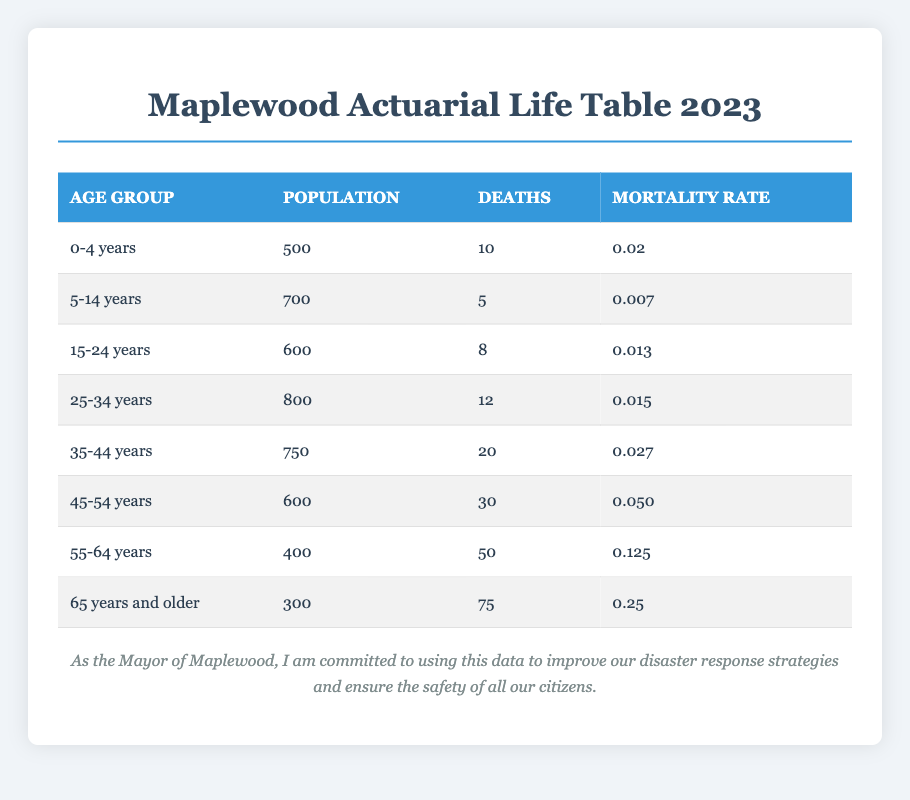What is the mortality rate for the age group 25-34 years? The table indicates that the mortality rate for the 25-34 year age group is listed directly under that category, which is 0.015.
Answer: 0.015 How many deaths were recorded in the age group 55-64 years? The number of deaths in the 55-64 year age group is noted in the table, and it shows a total of 50 deaths.
Answer: 50 What is the total population of the age groups 0-4 years and 5-14 years combined? To find the total population of the two age groups, we sum the populations: 500 (0-4 years) + 700 (5-14 years) = 1200.
Answer: 1200 Is the mortality rate for the age group 15-24 years higher than that for the age group 0-4 years? The mortality rate for 15-24 years is 0.013, compared to 0.02 for 0-4 years. Since 0.013 is less than 0.02, the statement is false.
Answer: No What is the average mortality rate across all age groups in the table? To compute the average mortality rate, we sum all mortality rates: 0.02 + 0.007 + 0.013 + 0.015 + 0.027 + 0.050 + 0.125 + 0.25 = 0.517, and divide by the number of age groups (8): 0.517 / 8 = 0.064625. Thus, the average mortality rate is approximately 0.0646.
Answer: 0.0646 Which age group has the highest mortality rate? By examining the mortality rates in the table, it is clear that the age group 65 years and older has the highest rate at 0.25.
Answer: 65 years and older What is the total number of deaths in the age group 45-54 years and 55-64 years combined? To find the total deaths in these age groups, we add 30 (45-54 years) + 50 (55-64 years) = 80.
Answer: 80 Is the total population of the age group 35-44 years less than that of the age group 45-54 years? The population for 35-44 years is 750 and for 45-54 years is 600. Since 750 is greater than 600, the statement is false.
Answer: No 